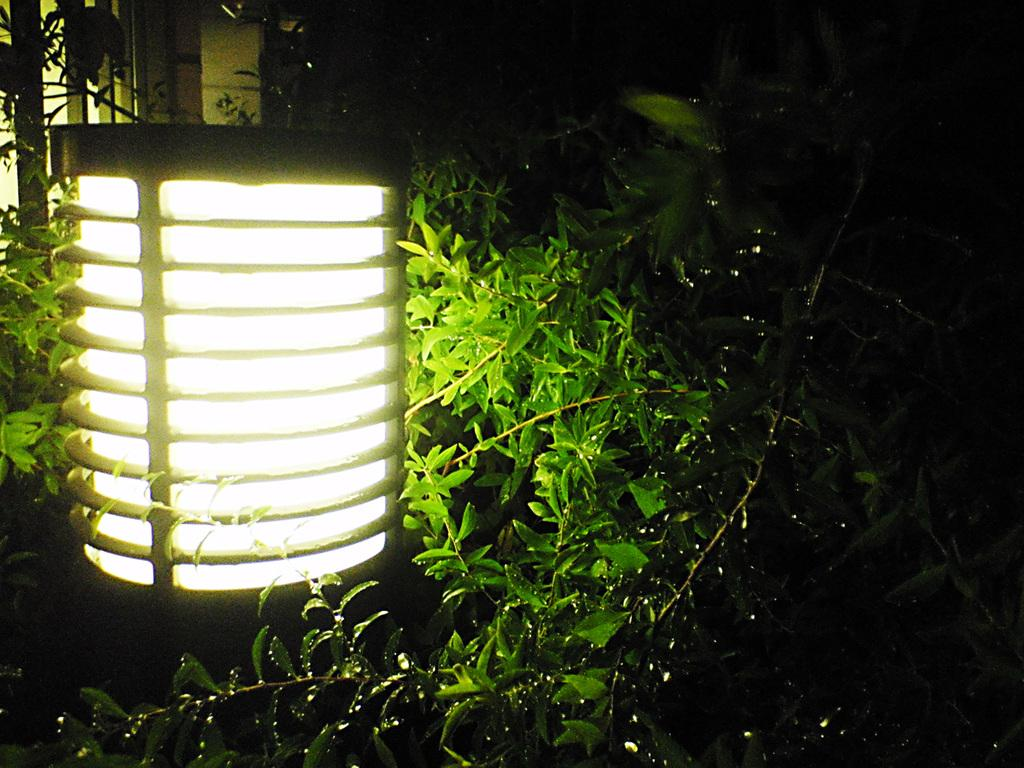What is present in the image that provides illumination? There is a light in the image. What type of natural elements can be seen in the image? There are trees in the image. How would you describe the overall brightness of the image? The image is a little dark. Can you see a cushion on the ground in the image? There is no mention of a cushion in the provided facts, so we cannot determine if one is present in the image. 